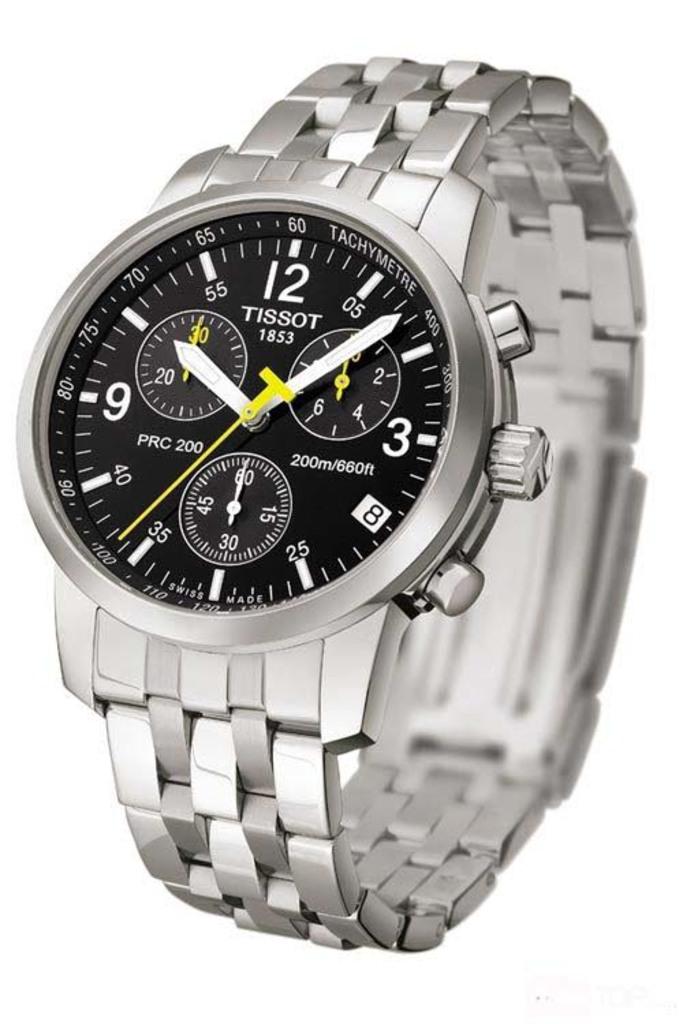What brand is this watch?
Provide a succinct answer. Tissot. What time is on the watch face?
Give a very brief answer. 10:07. 